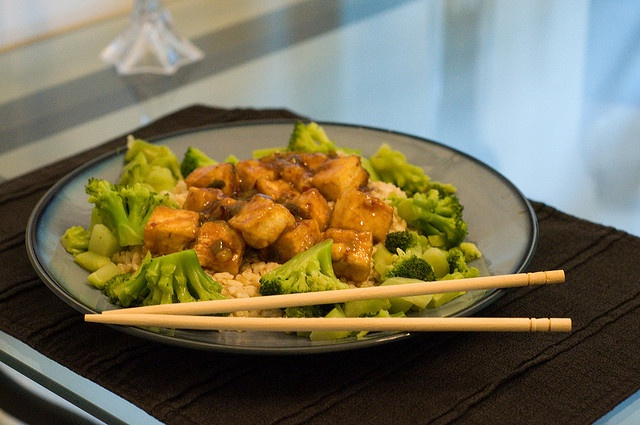Describe the objects in this image and their specific colors. I can see dining table in black, darkgray, lightblue, and gray tones, broccoli in lightgray, olive, tan, and darkgreen tones, broccoli in lightgray, olive, and black tones, broccoli in lightgray and olive tones, and broccoli in lightgray, olive, gold, and black tones in this image. 